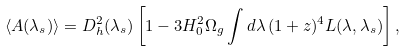<formula> <loc_0><loc_0><loc_500><loc_500>\langle A ( \lambda _ { s } ) \rangle = D _ { h } ^ { 2 } ( \lambda _ { s } ) \left [ 1 - 3 H _ { 0 } ^ { 2 } \Omega _ { g } \int d \lambda \, ( 1 + z ) ^ { 4 } L ( \lambda , \lambda _ { s } ) \right ] ,</formula> 